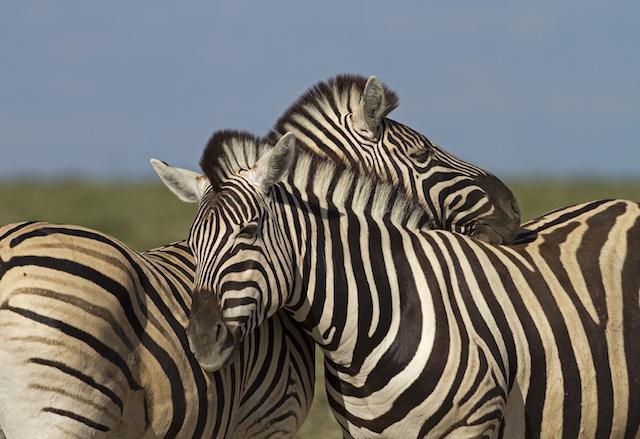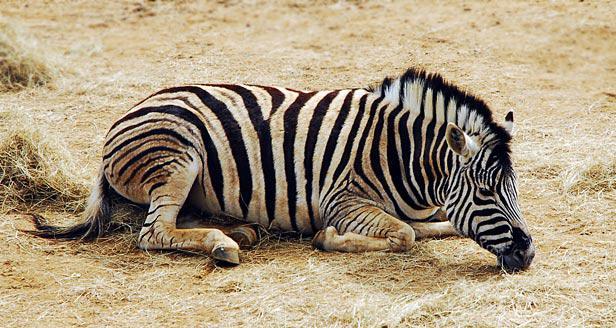The first image is the image on the left, the second image is the image on the right. Evaluate the accuracy of this statement regarding the images: "One image includes a zebra lying completely flat on the ground, and the othe image includes a zebra with its head lifted, mouth open and teeth showing in a braying pose.". Is it true? Answer yes or no. No. The first image is the image on the left, the second image is the image on the right. Given the left and right images, does the statement "One of the images features a single zebra laying completely sideways on the ground." hold true? Answer yes or no. No. 